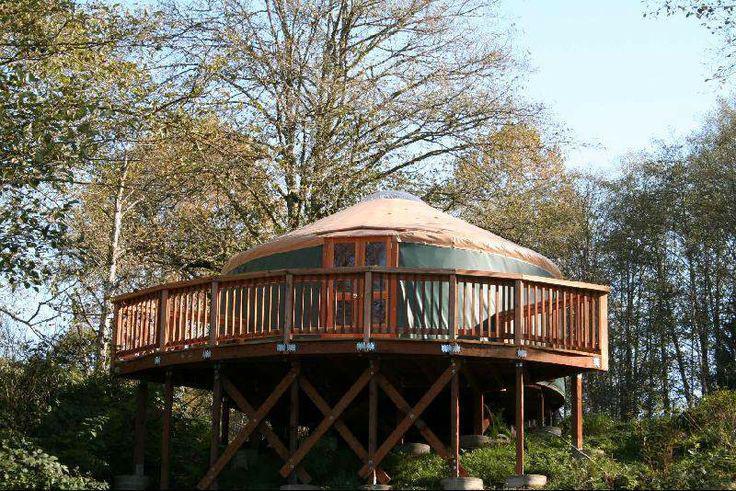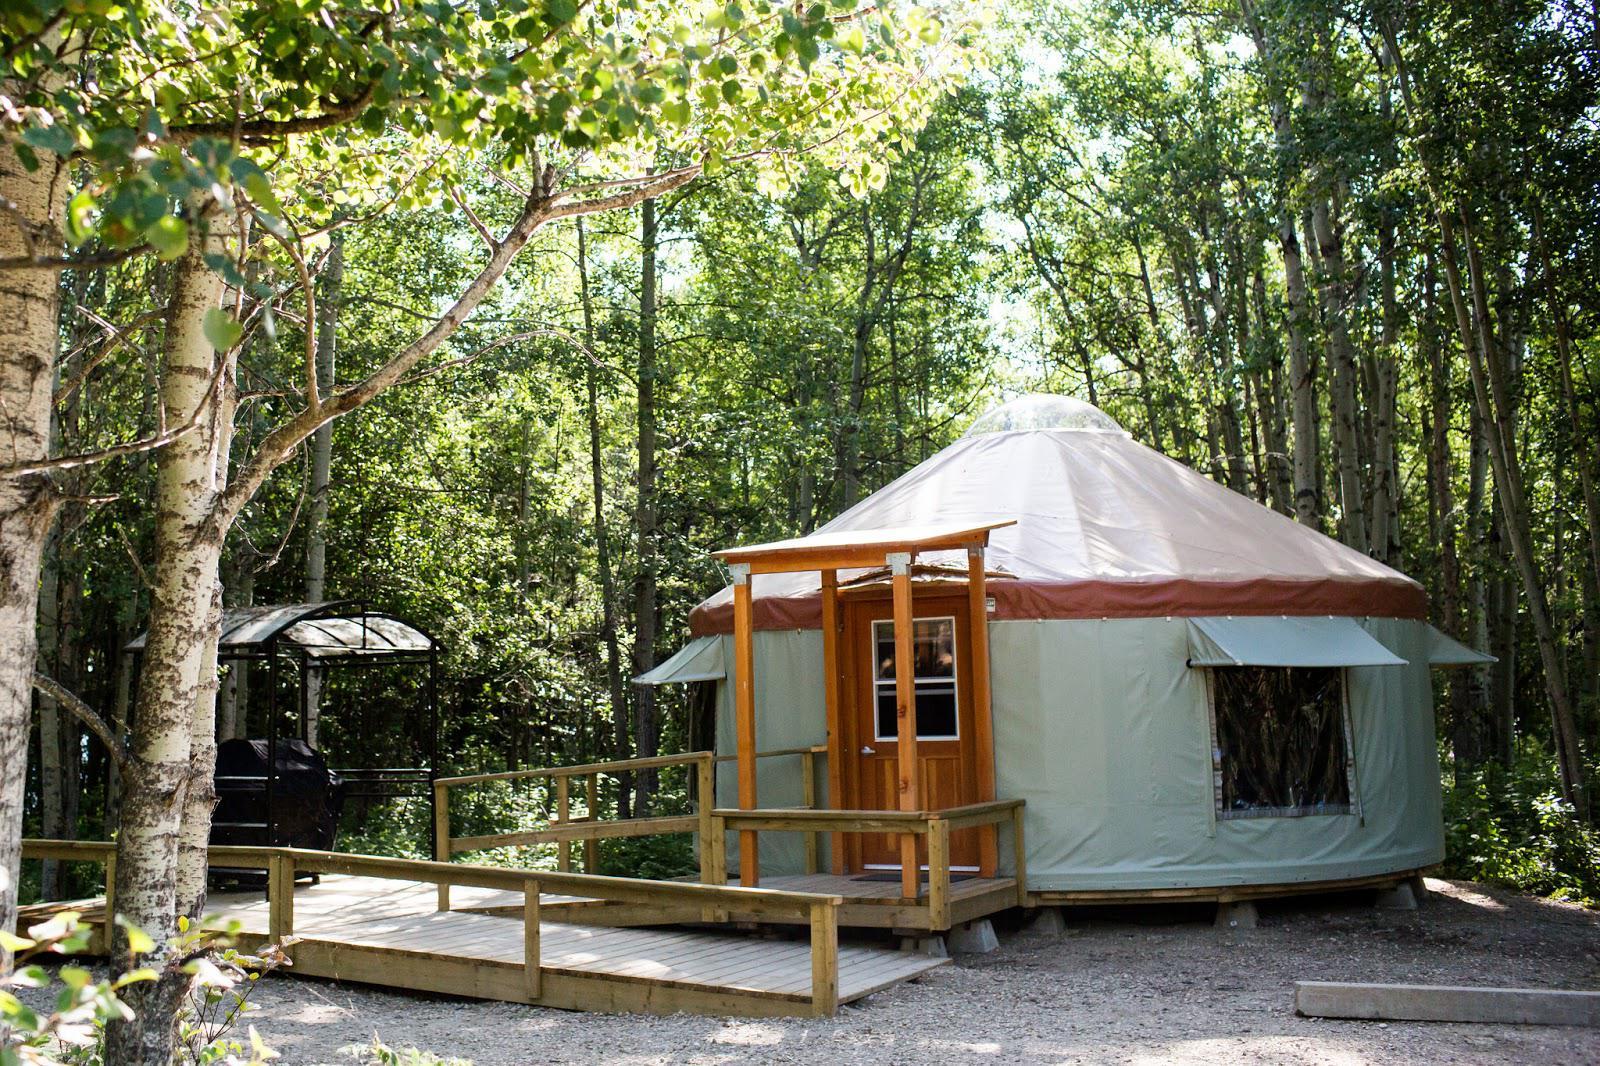The first image is the image on the left, the second image is the image on the right. Given the left and right images, does the statement "An image shows a round house on stilts surrounded by a railing and deck." hold true? Answer yes or no. Yes. The first image is the image on the left, the second image is the image on the right. Evaluate the accuracy of this statement regarding the images: "In one image, a round house has a round wrap-around porch.". Is it true? Answer yes or no. Yes. 